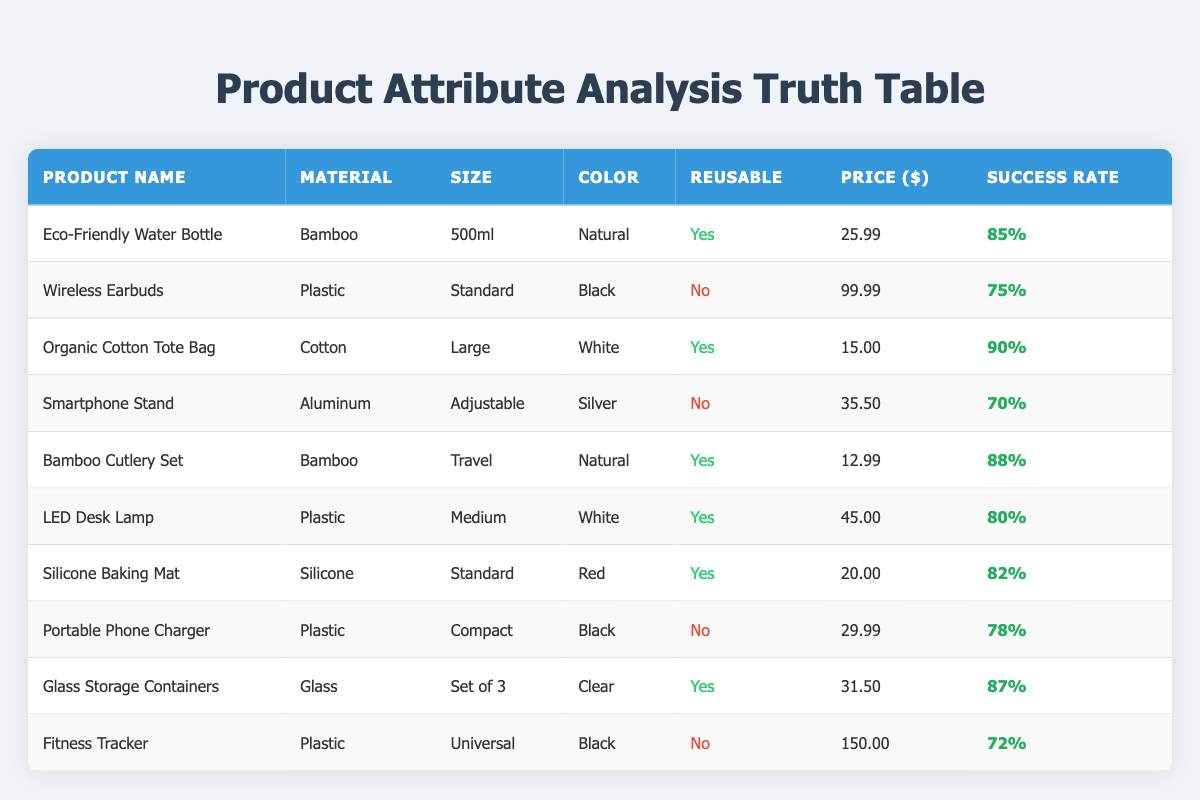What is the success rate of the Eco-Friendly Water Bottle? The success rate for the Eco-Friendly Water Bottle is found in the 'Success Rate' column corresponding to the product name. It is listed as 85%.
Answer: 85% Which product has the highest success rate? To find the highest success rate, we scan the 'Success Rate' column and identify that the Organic Cotton Tote Bag has the highest success rate at 90%.
Answer: Organic Cotton Tote Bag What is the price difference between the Fitness Tracker and the Wireless Earbuds? The price of the Fitness Tracker is $150.00, and the Wireless Earbuds is $99.99. The difference is calculated by subtracting the lower price from the higher price: 150.00 - 99.99 = 50.01.
Answer: 50.01 Are all products made from reusable materials? To answer this question, we need to check the 'Reusable' column for each product. The Wireless Earbuds, Smartphone Stand, Portable Phone Charger, and Fitness Tracker are not reusable, indicating that not all products are made from reusable materials.
Answer: No What percentage of the total products are reusable? There are 10 products listed. The reusable products are: Eco-Friendly Water Bottle, Organic Cotton Tote Bag, Bamboo Cutlery Set, LED Desk Lamp, Silicone Baking Mat, and Glass Storage Containers, totaling 6 reusable products. The percentage is calculated as (6/10) * 100 = 60%.
Answer: 60% Which product is made of aluminum and what is its success rate? The table indicates that the product made of aluminum is the Smartphone Stand. Its corresponding success rate is 70%, found in the 'Success Rate' column beside its entry.
Answer: 70% If we consider only the reusable products, what is the average success rate? From the reusable products, we gather the success rates: 85%, 90%, 88%, 80%, 82%, and 87%. We add them up: 85 + 90 + 88 + 80 + 82 + 87 = 512. Then, we divide by the number of reusable products (6): 512/6 = approximately 85.33.
Answer: Approximately 85.33 What color is the Organic Cotton Tote Bag? The color of the Organic Cotton Tote Bag can be found in the 'Color' column of its row. It is listed as White.
Answer: White Is there any product priced under 15 dollars? By examining the 'Price' column for prices less than $15, we find that only the Organic Cotton Tote Bag, priced at $15.00, appears not to meet this criterion. Thus, there are no products priced under 15 dollars.
Answer: No 